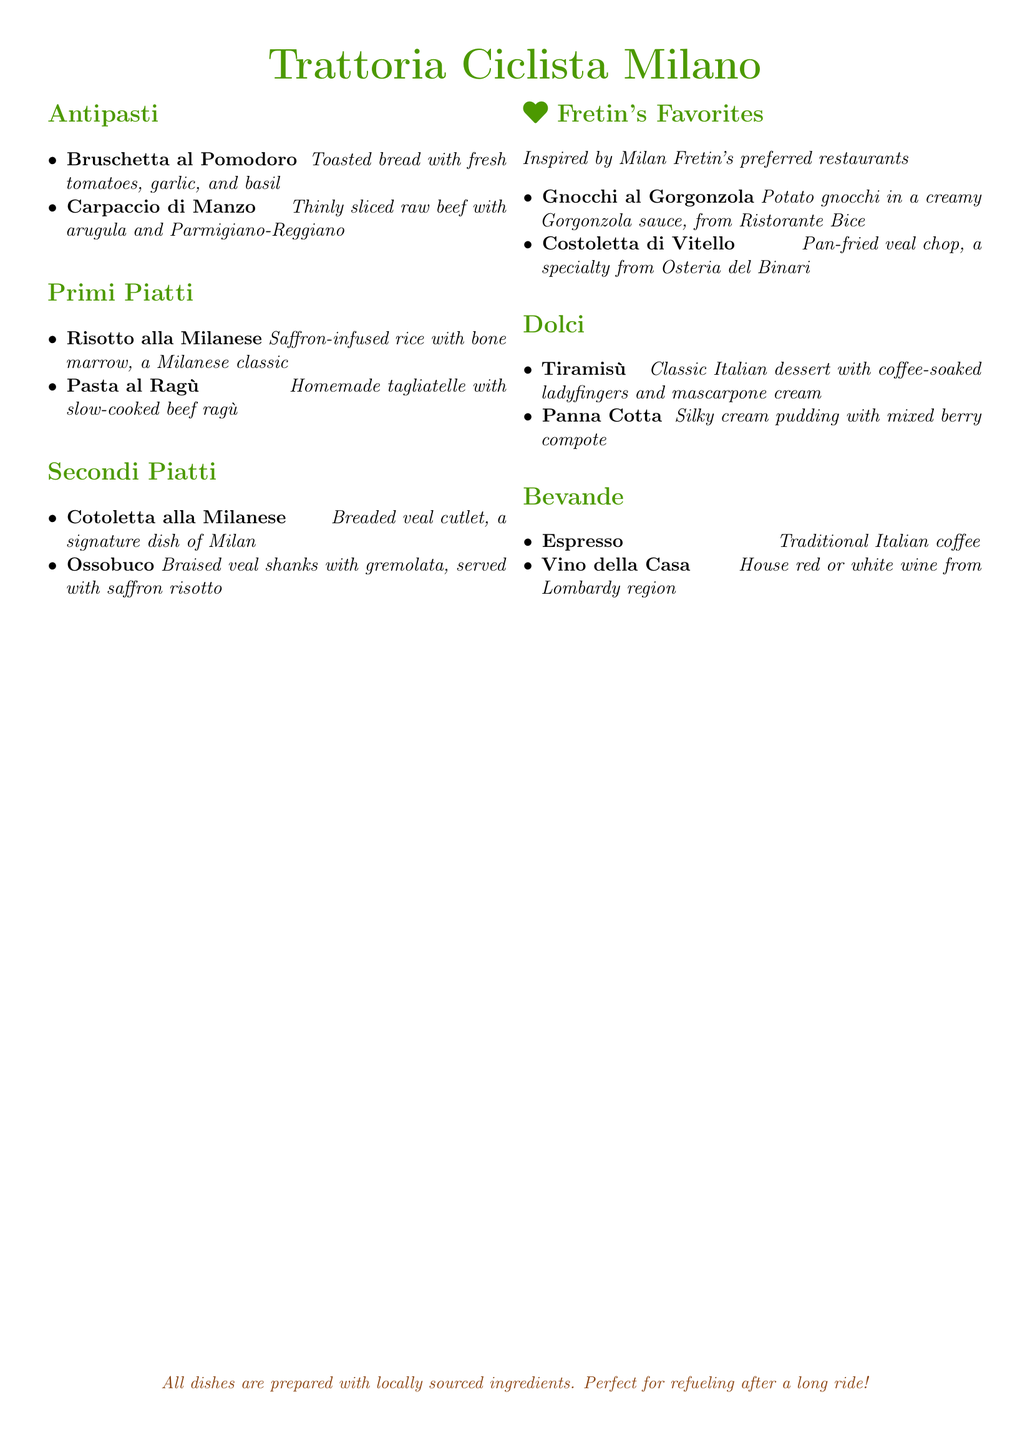What type of restaurant is Trattoria Ciclista Milano? The document indicates that it is an Italian trattoria, emphasizing Milan's culinary scene.
Answer: Italian trattoria What is the special section dedicated to? The section highlights dishes inspired by Milan Fretin's favorite restaurants.
Answer: Fretin's favorites What is the main ingredient in Risotto alla Milanese? The main ingredient is saffron, which gives the dish its distinctive color and flavor.
Answer: Saffron Where is Gnocchi al Gorgonzola from? The document specifies that it is from Ristorante Bice, one of Fretin's favorite spots.
Answer: Ristorante Bice What dessert is described as having coffee-soaked ladyfingers? The dessert that features coffee-soaked ladyfingers is tiramisù.
Answer: Tiramisù What is served with Ossobuco? The dish is served with saffron risotto, complementing the flavors of the braised veal shanks.
Answer: Saffron risotto How many antipasti are listed on the menu? The document includes two antipasti options.
Answer: Two What type of wine is featured under Bevande? The menu mentions house red or white wine specific to the Lombardy region.
Answer: House red or white wine What kind of pudding is Panna Cotta? The document describes it as a silky cream pudding.
Answer: Silky cream pudding 